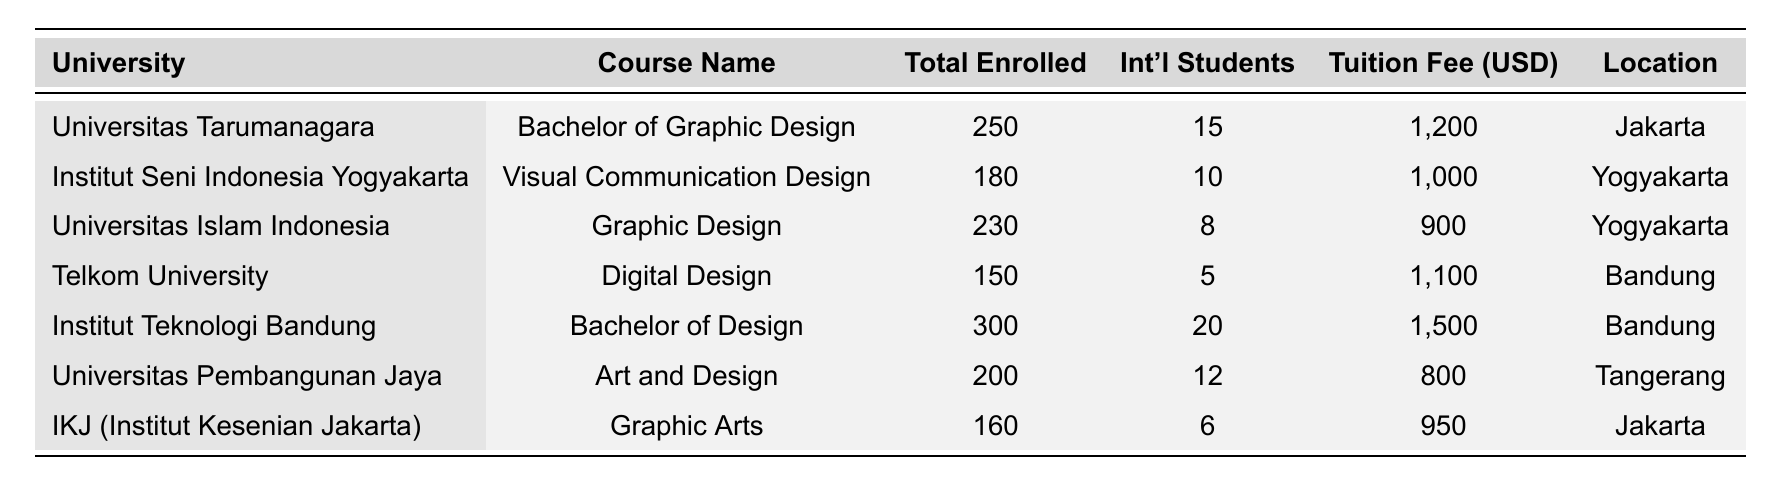What is the total number of enrolled students across all universities? To find the total number of enrolled students, sum the values in the "Total Enrolled" column: 250 + 180 + 230 + 150 + 300 + 200 + 160 = 1470.
Answer: 1470 Which university has the highest tuition fee? By checking the "Tuition Fee" column, Universitas Teknologi Bandung has the highest fee at 1500 USD.
Answer: Universitas Teknologi Bandung How many international students are enrolled in Universitas Pembangunan Jaya? The number of international students in Universitas Pembangunan Jaya is specified in the "Int'l Students" column as 12.
Answer: 12 What is the average tuition fee for the graphic design programs? To calculate the average, sum the tuition fees: (1200 + 1000 + 900 + 1100 + 1500 + 800 + 950) = 6450, then divide by the number of programs (7): 6450 / 7 = 921.43.
Answer: 921.43 Is the total enrollment at IKJ greater than the total enrollment at Telkom University? The total enrollment at IKJ is 160, while at Telkom University it is 150. Since 160 > 150, the statement is true.
Answer: Yes How many universities have more than 200 students enrolled? Counting the universities with enrollments greater than 200: Universitas Tarumanagara (250), Universitas Islam Indonesia (230), and Institut Teknologi Bandung (300), which gives us a total of 3 universities.
Answer: 3 What percentage of total enrolled students are international students? To find the total number of international students: 15 + 10 + 8 + 5 + 20 + 12 + 6 = 76. Then divide by total enrolled (1470) and multiply by 100: (76 / 1470) * 100 = 5.17%.
Answer: 5.17% Which location has the most diverse graphic design programs? By analyzing the "Location" column, Bandung has 2 programs (Telkom University and Institut Teknologi Bandung), Yogyakarta has 2 programs (Institut Seni Indonesia Yogyakarta and Universitas Islam Indonesia), and Jakarta has 2 programs (Universitas Tarumanagara and IKJ), indicating all three locations are equally diverse.
Answer: Equal diversity What is the difference in total enrollment between the highest and lowest enrolled courses? The highest enrollment is 300 (Institut Teknologi Bandung), and the lowest is 150 (Telkom University). Therefore, the difference is 300 - 150 = 150.
Answer: 150 Are there more than 15 international students enrolled in any program? Yes, Universitas Teknologi Bandung has 20 international students, which is greater than 15.
Answer: Yes 